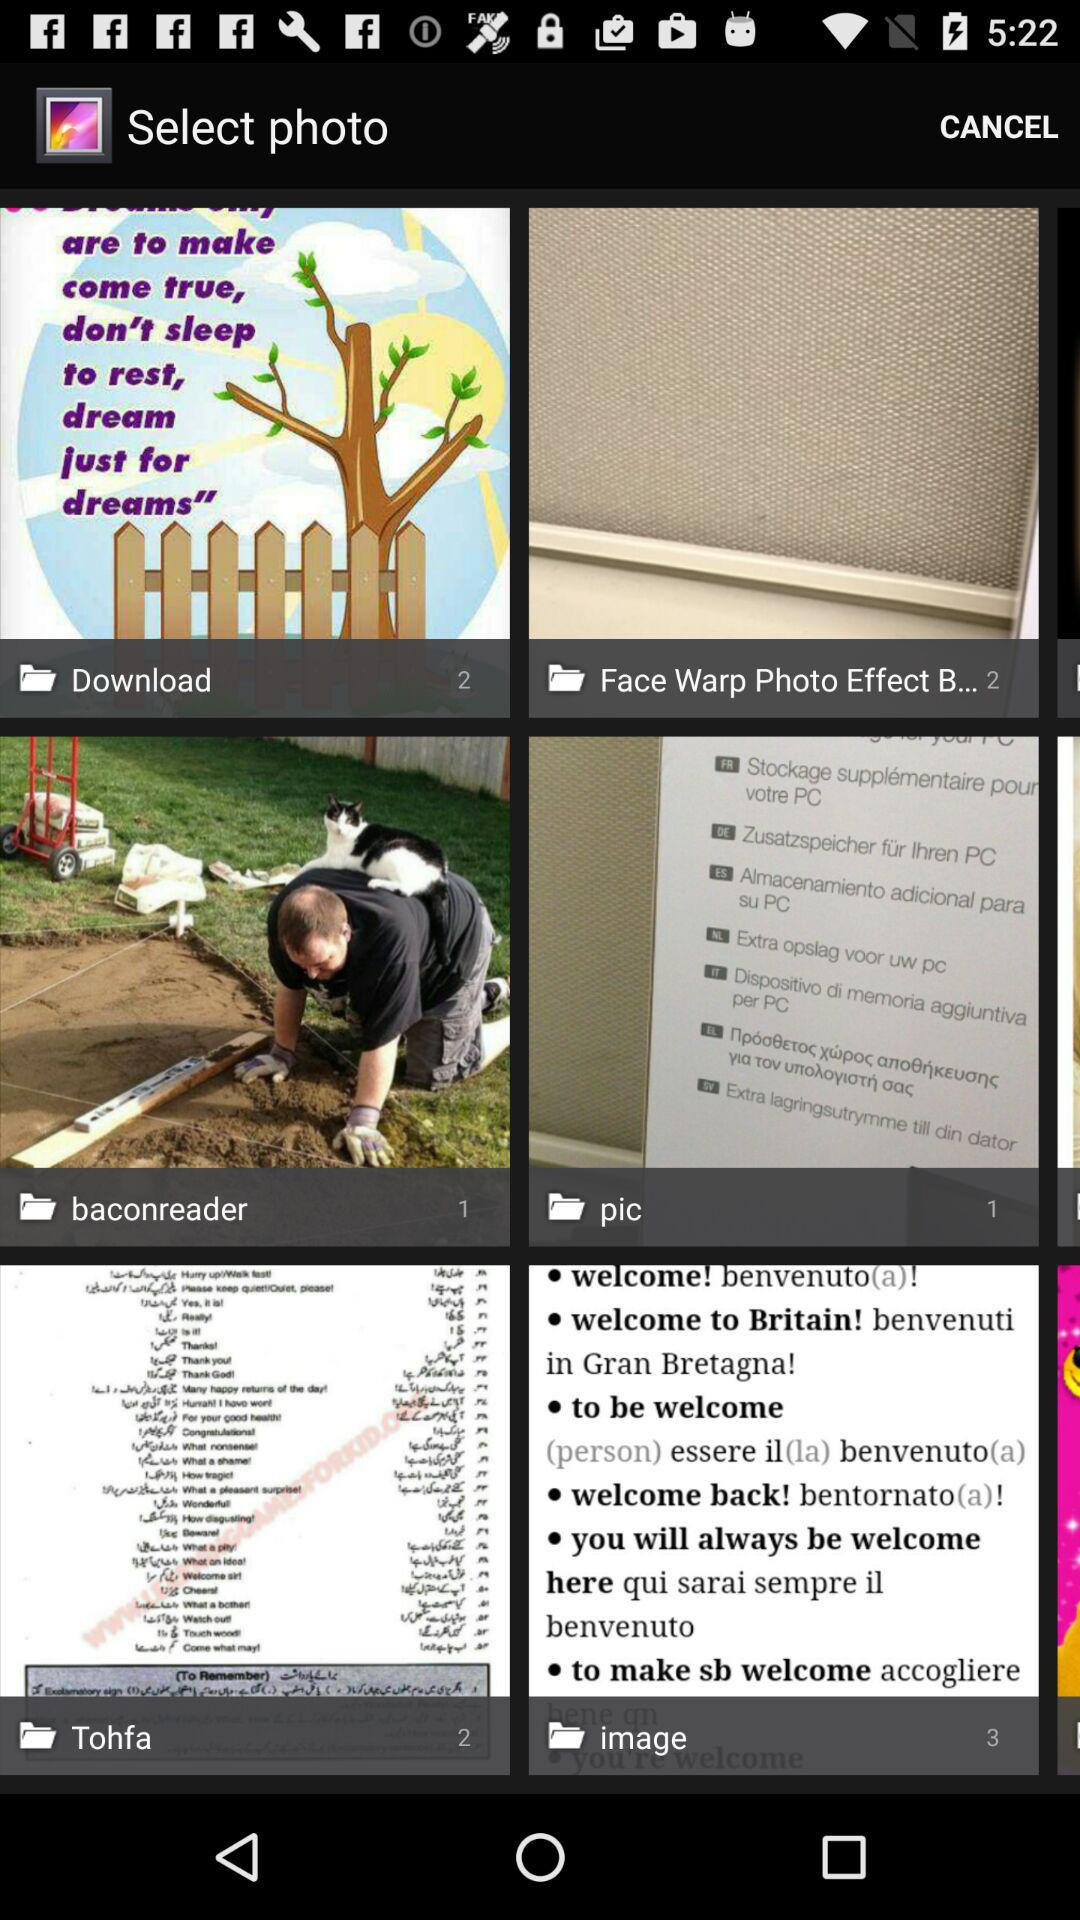How many photos are present in the "Tohfa"? There are 2 photos present in the "Tohfa". 